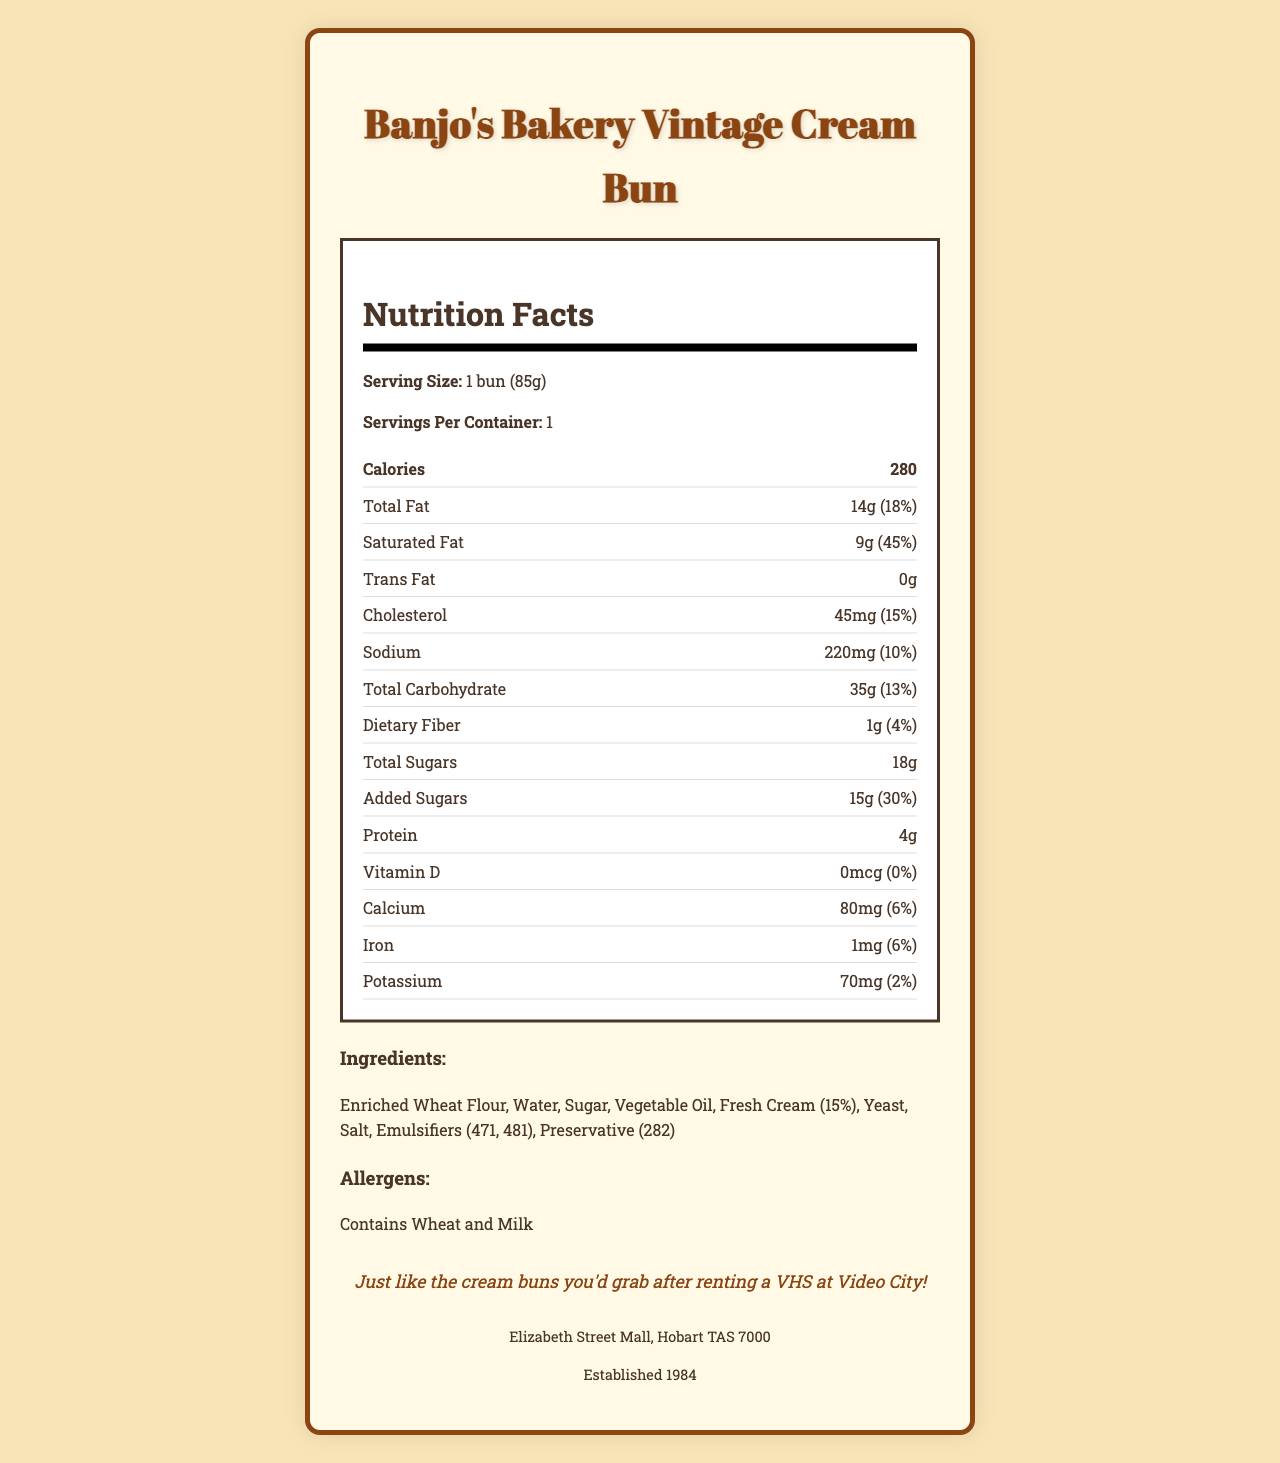what is the serving size of Banjo's Bakery Vintage Cream Bun? The document states that the serving size is 1 bun (85g).
Answer: 1 bun (85g) what is the total fat content in one serving? The document lists the total fat content as 14g, which is 18% of the daily value.
Answer: 14g (18%) how much added sugar does the bun contain? The document specifies that there are 15g of added sugars, which is 30% of the daily value.
Answer: 15g (30%) what are the allergens present in the cream bun? The document mentions that the allergens include wheat and milk.
Answer: Contains Wheat and Milk what is the established year of Banjo's Bakery? The document indicates that the bakery was established in 1984.
Answer: 1984 how many calories are in one bun? The document notes that each bun contains 280 calories.
Answer: 280 which ingredient is the most prominent in the bun? The first listed ingredient is usually the most prominent, here it is "Enriched Wheat Flour".
Answer: Enriched Wheat Flour what percentage of daily value is the sodium content? The document states that the sodium content is 220mg, which is 10% of the daily value.
Answer: 10% Does the bun contain trans fat? The document shows that the trans fat content is 0g, meaning it does not contain trans fat.
Answer: No From which street in Hobart is Banjo's Bakery located? The document notes that Banjo's Bakery is located in the Elizabeth Street Mall in Hobart.
Answer: Elizabeth Street Mall how many servings are there per container? A. 1 B. 2 C. 3 D. 4 The document clearly states that there is 1 serving per container.
Answer: A what is the protein content in the bun? A. 2g B. 3g C. 4g D. 5g The document lists the protein content as 4g.
Answer: C what is the percentage of daily value for calcium in the bun? The document states that the calcium amount is 80mg, which is 6% of the daily value.
Answer: 6% is the bun gluten-free? Given that it contains enriched wheat flour, the bun is not gluten-free.
Answer: No summarize the main idea of this document. The document's main idea is to present nutritional information, ingredient composition, and additional facts for Banjo's Bakery Vintage Cream Bun, designed to evoke nostalgia and inform potential customers.
Answer: The document provides detailed nutrition facts and ingredient information for Banjo's Bakery Vintage Cream Bun, including serving size, calorie content, fats, sugars, and allergens, accompanied by a nostalgic note and bakery information. What is the fiber content in the bun? The nutrition label indicates that the bun contains 1g of dietary fiber, contributing 4% to the daily value.
Answer: 1g (4%) What types of emulsifiers are used in the bun? The document lists emulsifiers 471 and 481 as part of the ingredients.
Answer: 471, 481 How much vitamin D does the bun contain? The document specifies that there is no vitamin D in the bun, as it lists 0mcg and 0% of the daily value.
Answer: 0mcg (0%) Does the document give the exact amount of potassium in the bun? The document specifies the bun contains 70mg of potassium, which is 2% of the daily value.
Answer: Yes what is the customer satisfaction rating for Banjo's Bakery? The document does not provide any information about customer satisfaction ratings.
Answer: Not enough information 